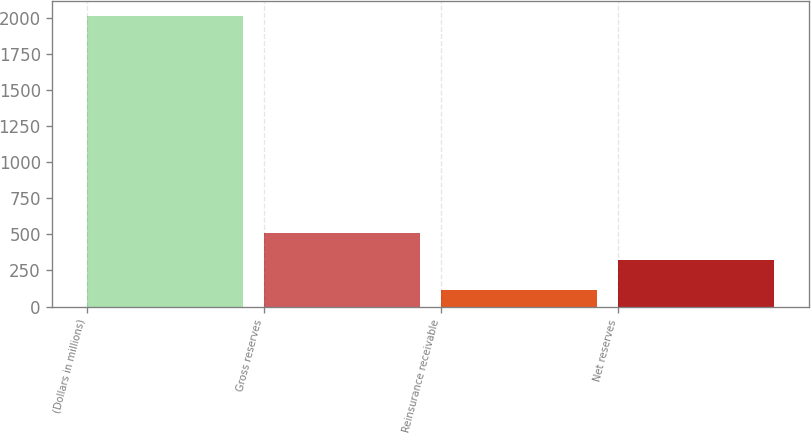Convert chart. <chart><loc_0><loc_0><loc_500><loc_500><bar_chart><fcel>(Dollars in millions)<fcel>Gross reserves<fcel>Reinsurance receivable<fcel>Net reserves<nl><fcel>2015<fcel>509.75<fcel>113.5<fcel>319.6<nl></chart> 